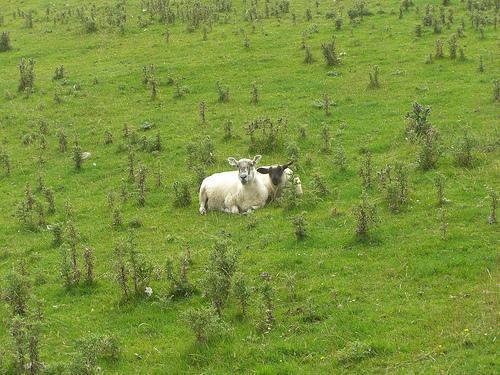How many animals are pictured?
Give a very brief answer. 2. 